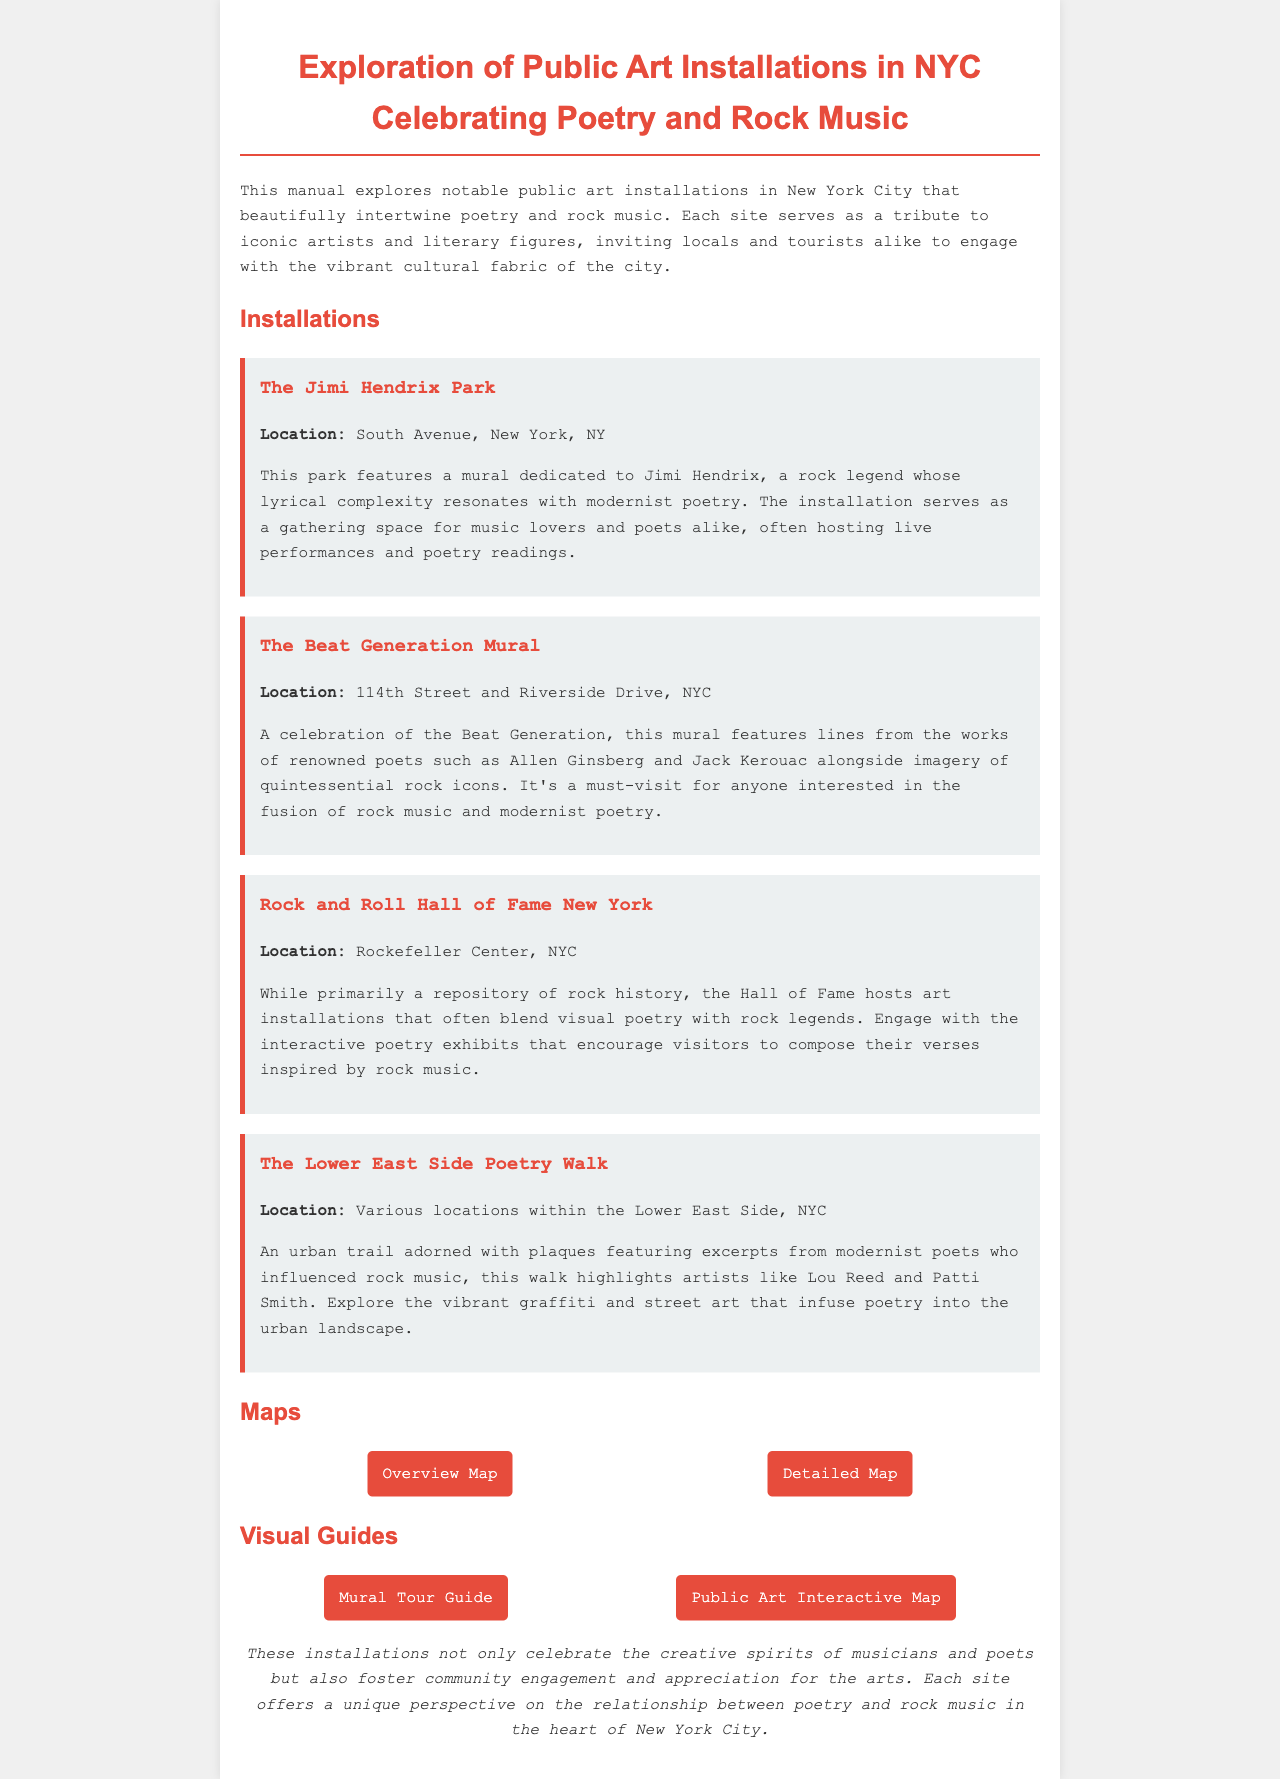what is the title of the manual? The title of the manual is stated at the top of the document under the header.
Answer: Exploration of Public Art Installations in NYC Celebrating Poetry and Rock Music how many installations are featured in the manual? The manual lists four distinct art installations related to poetry and rock music.
Answer: 4 what is the location of The Jimi Hendrix Park? The location is detailed in the description of the installation.
Answer: South Avenue, New York, NY which artist is celebrated in The Beat Generation Mural? The mural highlights works from notable poets of the Beat Generation.
Answer: Allen Ginsberg and Jack Kerouac what type of exhibits can be found at the Rock and Roll Hall of Fame? The document specifies that the Hall of Fame features art installations blending visual poetry and rock legends.
Answer: Interactive poetry exhibits which installation is located on 114th Street and Riverside Drive? The location mentioned corresponds to one specific installation in the document.
Answer: The Beat Generation Mural what interactive resource is provided for exploring public art? The manual includes links to guides that help locate public art in NYC, contributing to engagement with installations.
Answer: Public Art Interactive Map name one poet mentioned in connection with The Lower East Side Poetry Walk. The text indicates particular poets who influenced rock music through the urban trail.
Answer: Lou Reed 